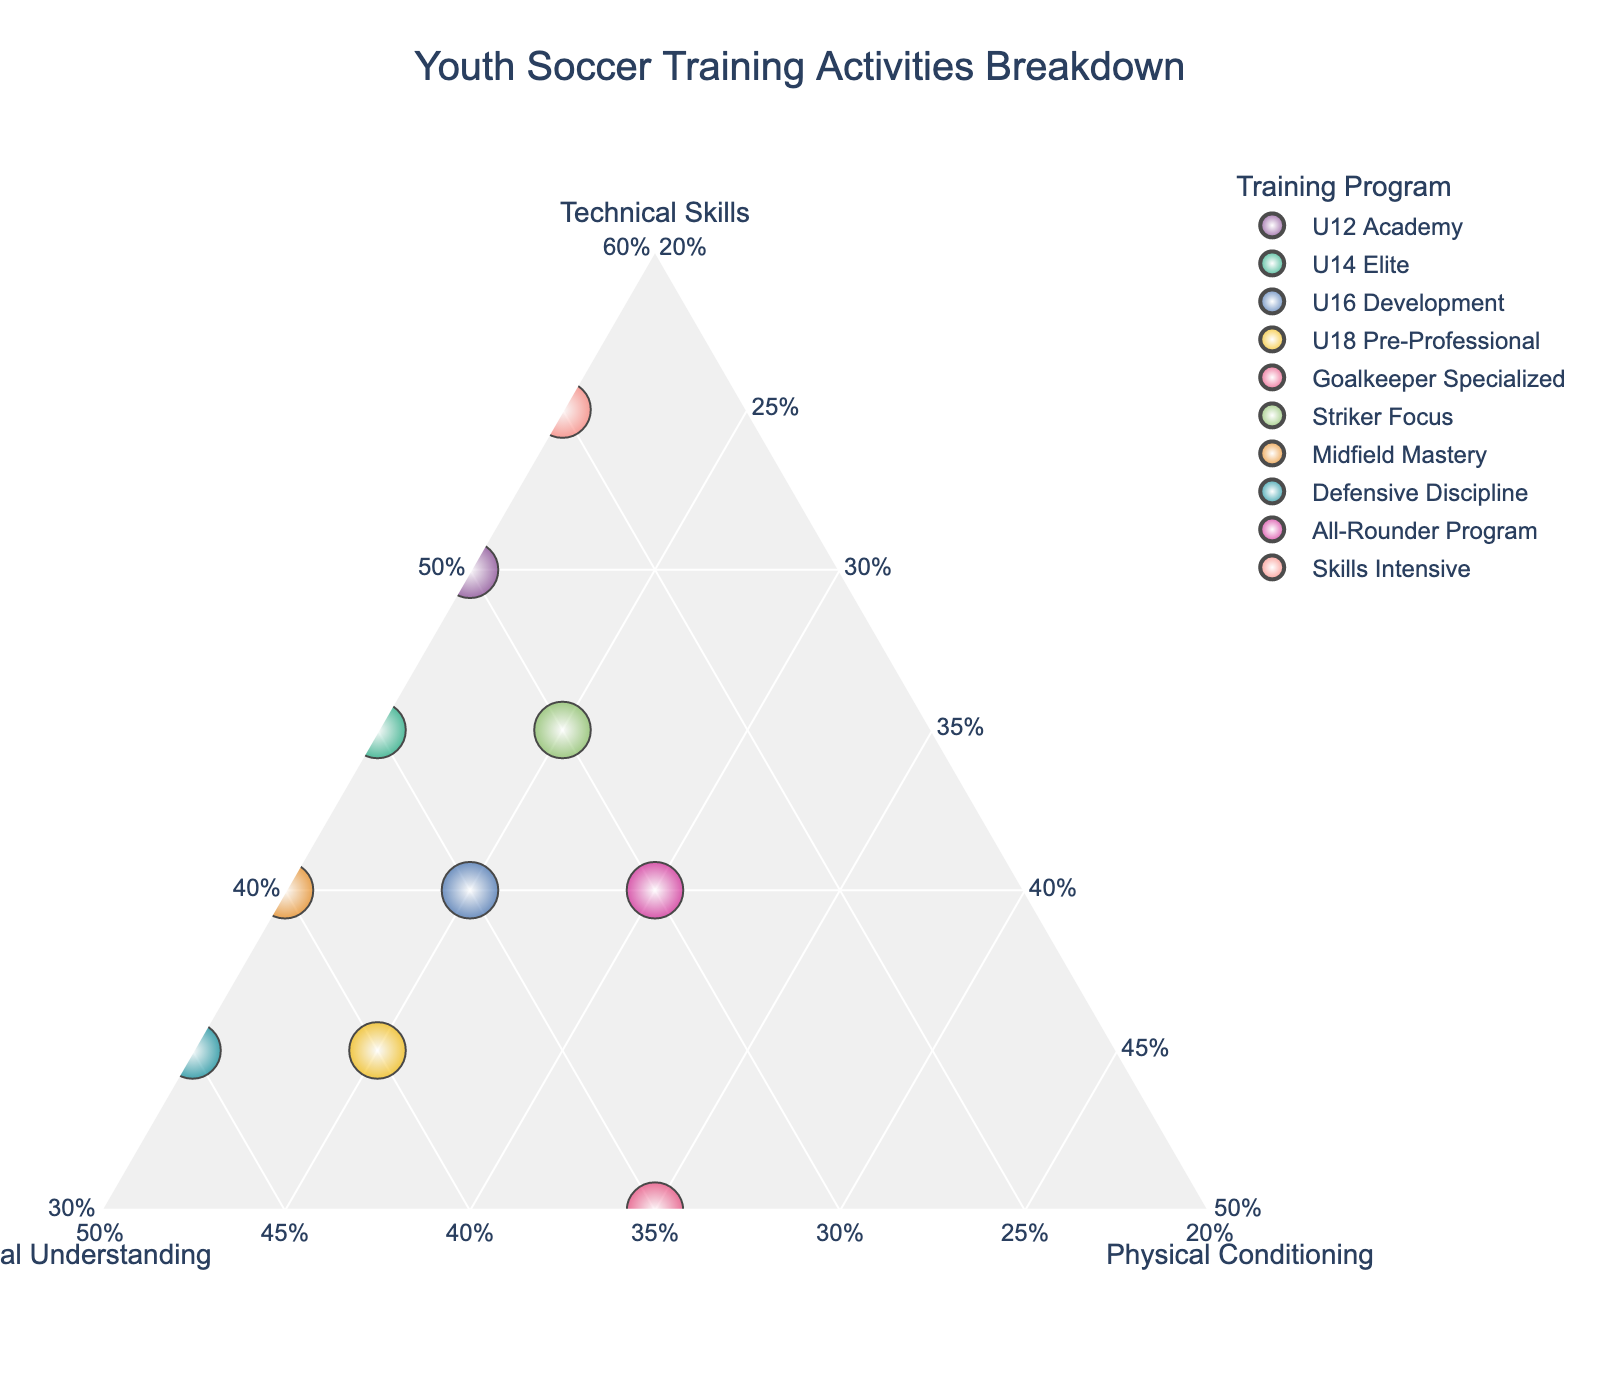What's the title of the figure? The title is typically displayed at the top of the plot. By looking at the figure, you will see the title text.
Answer: Youth Soccer Training Activities Breakdown How many training programs focus 40% or more on Tactical Understanding? Look at the 'Tactical Understanding' axis and count the data points that meet or exceed 40% on that scale.
Answer: 4 Which training activity places the most emphasis on Physical Conditioning? Find the point that is closest to the 'Physical Conditioning' axis maximum value.
Answer: Goalkeeper Specialized What is the range of Technical Skills percentages in the dataset? Identify the highest and lowest values on the Technical Skills axis. The range is calculated as the difference between these values.
Answer: 30% to 55% Which two training programs have the same percentage for Physical Conditioning? Look for data points that share the same value on the 'Physical Conditioning' axis.
Answer: U16 Development and U18 Pre-Professional (both 25%) What activity has the highest percentage of Technical Skills and how much is it? Identify the data point with the highest value on the 'Technical Skills' axis.
Answer: Skills Intensive with 55% How many activities allocate exactly 20% to Physical Conditioning? Look for data points with a value of 20% on the 'Physical Conditioning' axis and count them.
Answer: 6 Which activity has an equal distribution (equal percentages) in two of the categories? Look for data points that have the same value in two categories by examining the values on the axes.
Answer: Goalkeeper Specialized (30% Technical Skills and 35% Tactical Understanding) Among Striker Focus and Defensive Discipline, which one spends more time on Tactical Understanding? Compare the values on the 'Tactical Understanding' axis for both activities.
Answer: Defensive Discipline What's the median percentage for Tactical Understanding across all activities? Organize the Tactical Understanding percentages from lowest to highest and find the middle value. If the number of activities is even, the median is the average of the two middle numbers.
Answer: 35% 